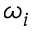<formula> <loc_0><loc_0><loc_500><loc_500>\omega _ { i }</formula> 